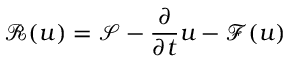<formula> <loc_0><loc_0><loc_500><loc_500>\mathcal { R } ( u ) = \mathcal { S } - \frac { \partial } { \partial t } u - \mathcal { F } ( u )</formula> 